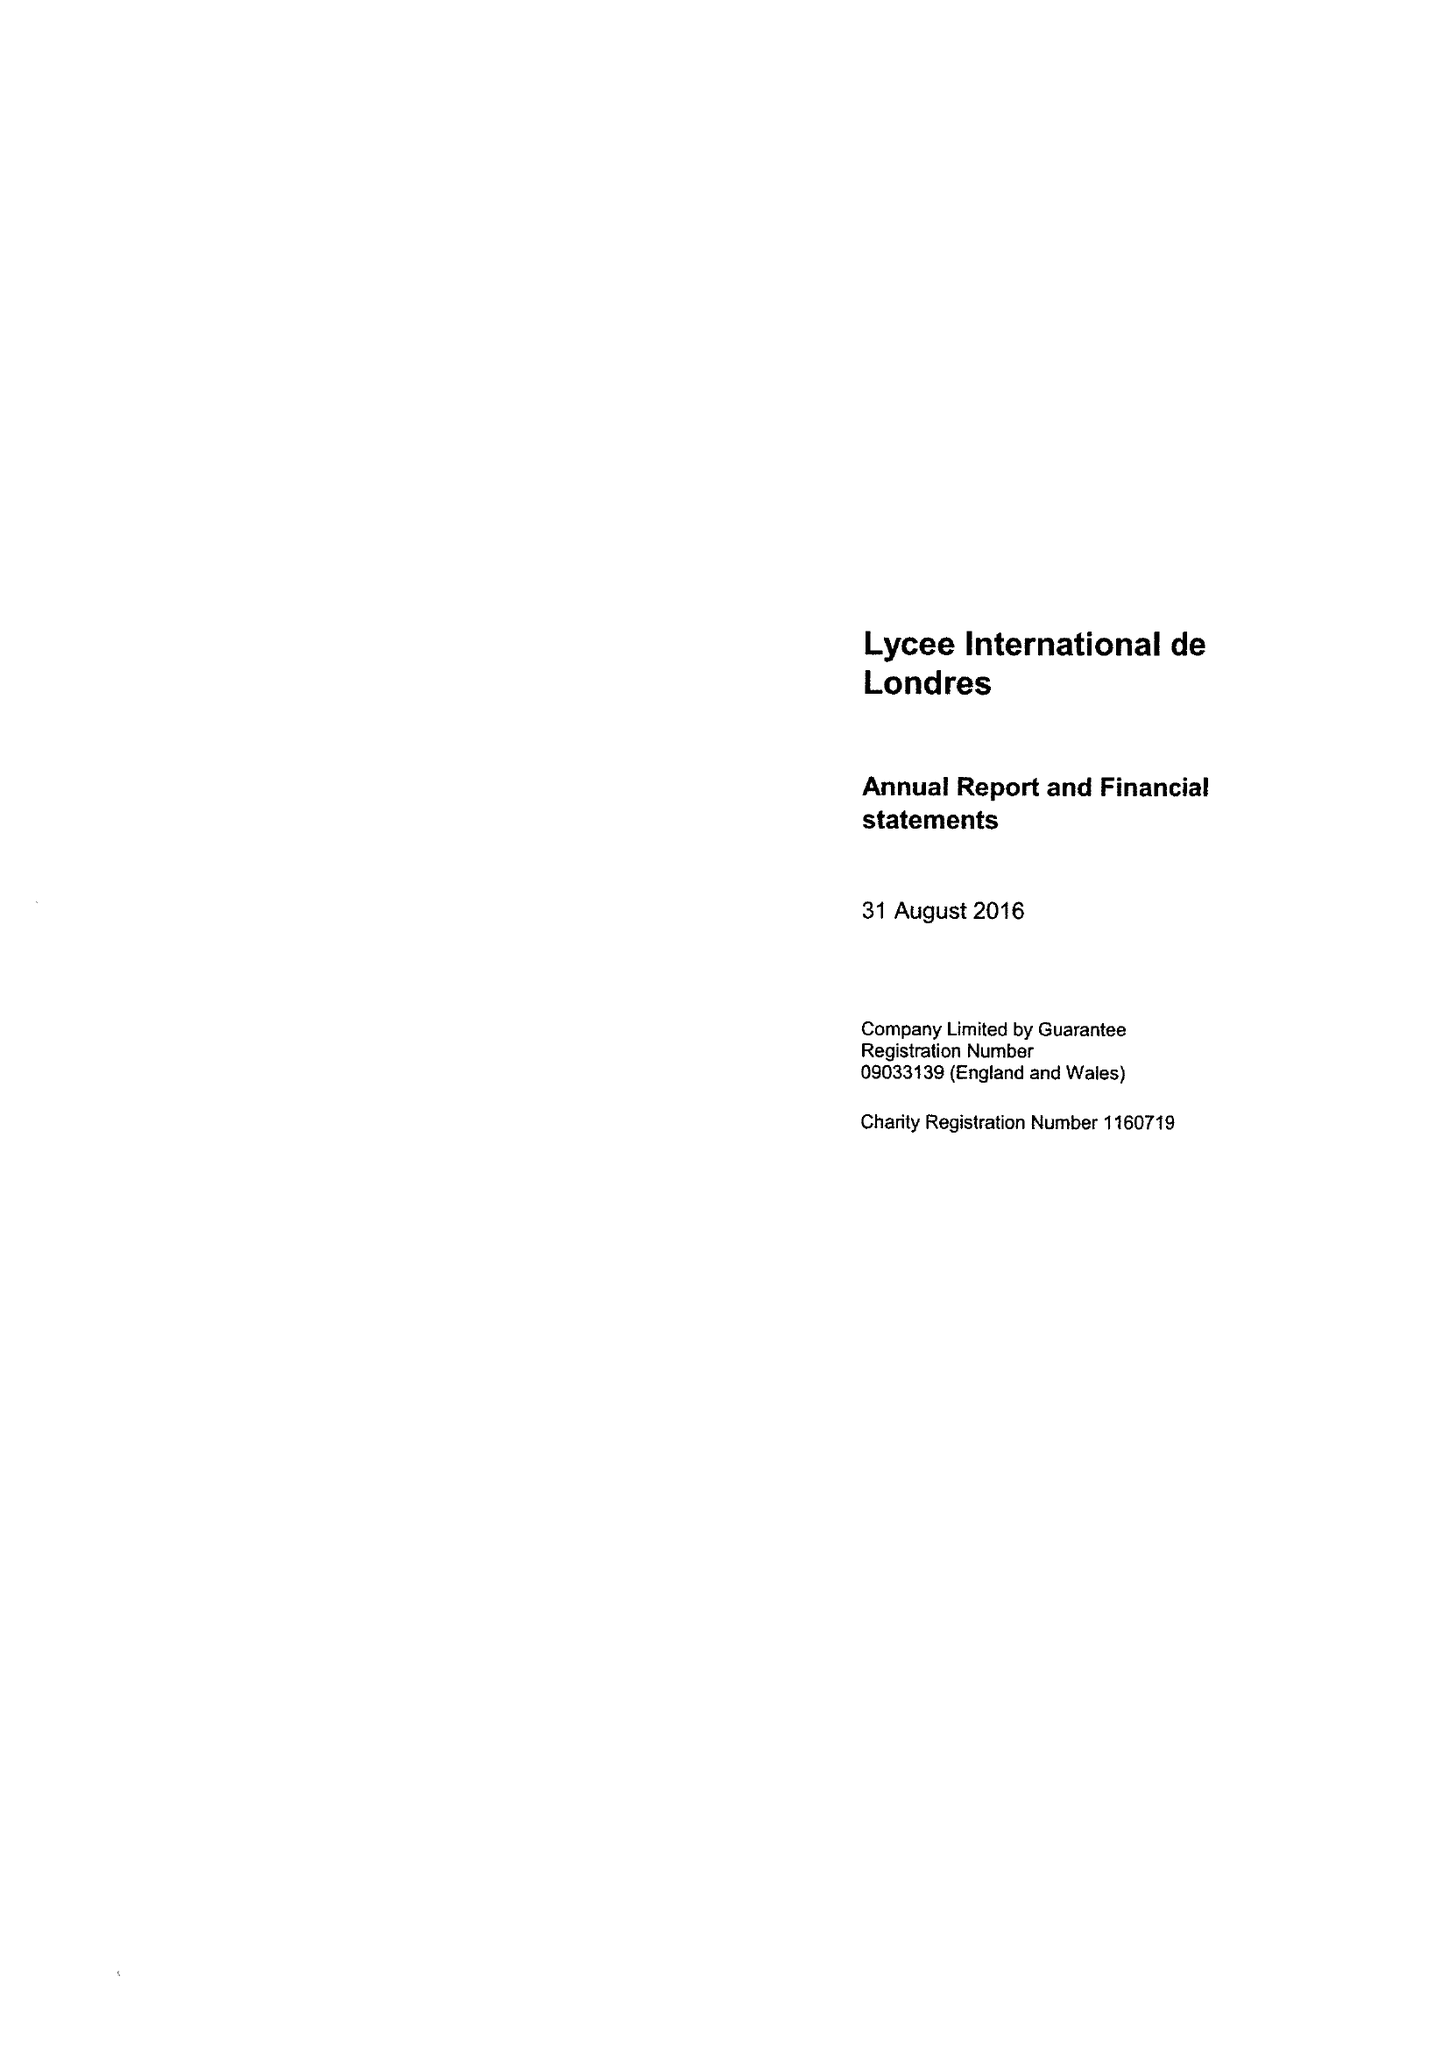What is the value for the charity_number?
Answer the question using a single word or phrase. 1160719 